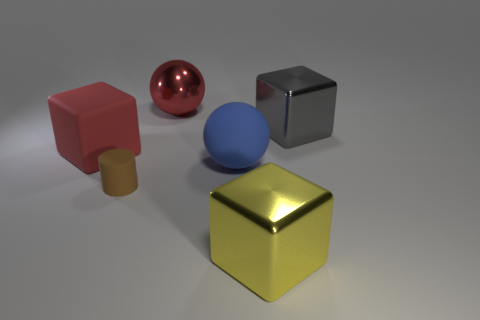Are the red object behind the large matte cube and the big red thing that is to the left of the tiny brown matte thing made of the same material?
Provide a succinct answer. No. What number of objects are brown matte cylinders in front of the large gray block or yellow cylinders?
Keep it short and to the point. 1. Is the number of big red spheres that are behind the cylinder less than the number of blue things on the right side of the big gray thing?
Provide a succinct answer. No. What number of other things are there of the same size as the red sphere?
Offer a very short reply. 4. Are the large red block and the big thing behind the large gray object made of the same material?
Give a very brief answer. No. How many things are either blocks on the right side of the blue rubber thing or brown rubber cylinders in front of the red metal object?
Give a very brief answer. 3. The big metal sphere has what color?
Your answer should be compact. Red. Is the number of brown cylinders that are right of the rubber cylinder less than the number of red matte blocks?
Offer a terse response. Yes. Is there anything else that is the same shape as the tiny brown matte thing?
Your response must be concise. No. Are any big red matte objects visible?
Make the answer very short. Yes. 